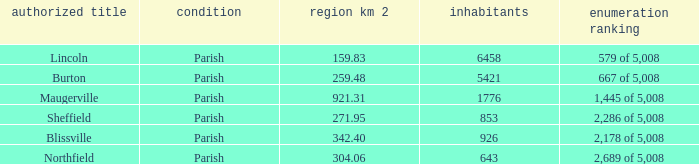What are the census ranking(s) of maugerville? 1,445 of 5,008. 